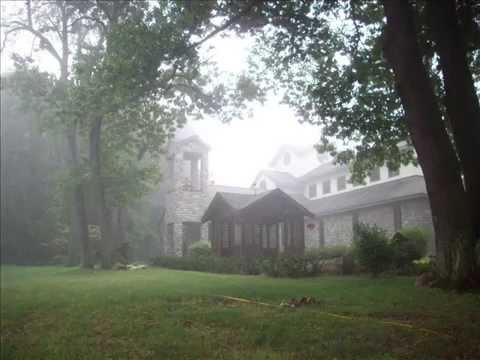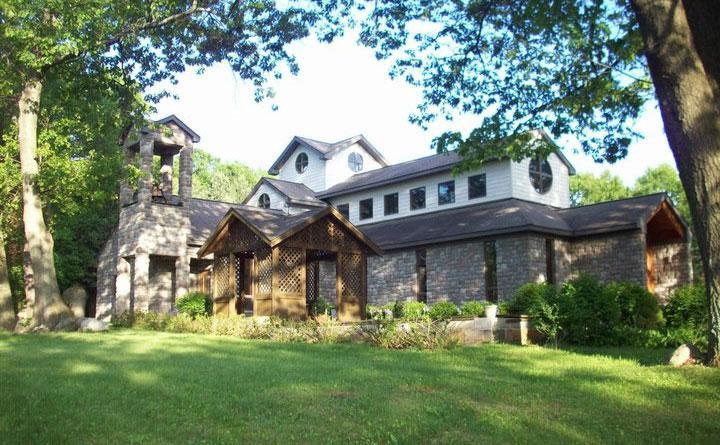The first image is the image on the left, the second image is the image on the right. Assess this claim about the two images: "A bell tower is visible in at least one image.". Correct or not? Answer yes or no. Yes. 